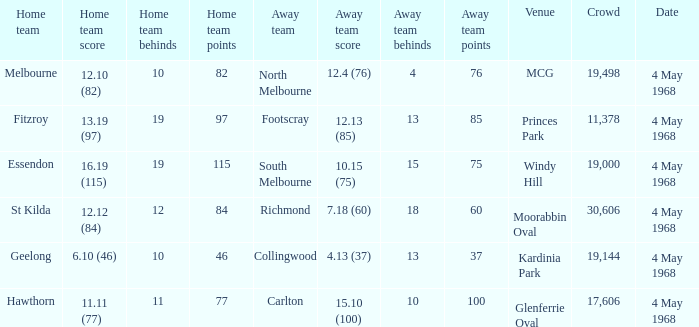What home team played at MCG? North Melbourne. 